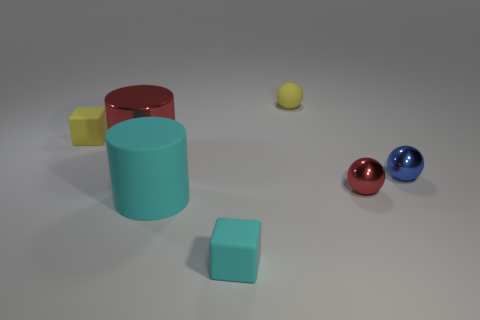Is the number of tiny shiny objects greater than the number of tiny yellow spheres?
Ensure brevity in your answer.  Yes. What number of red cylinders are the same material as the small blue sphere?
Offer a very short reply. 1. Is the shape of the blue metal thing the same as the tiny red metallic thing?
Offer a very short reply. Yes. What size is the matte cube in front of the tiny metal sphere in front of the blue sphere in front of the yellow rubber block?
Keep it short and to the point. Small. There is a yellow rubber object to the right of the big red object; is there a shiny object that is in front of it?
Your answer should be compact. Yes. What number of spheres are in front of the metal thing right of the red shiny thing that is on the right side of the small cyan matte object?
Give a very brief answer. 1. There is a small matte object that is both on the right side of the cyan cylinder and behind the cyan matte cylinder; what color is it?
Your response must be concise. Yellow. How many things have the same color as the big metal cylinder?
Your answer should be compact. 1. What number of cylinders are big cyan rubber objects or red metal things?
Provide a short and direct response. 2. There is a metal object that is the same size as the blue ball; what is its color?
Your response must be concise. Red. 